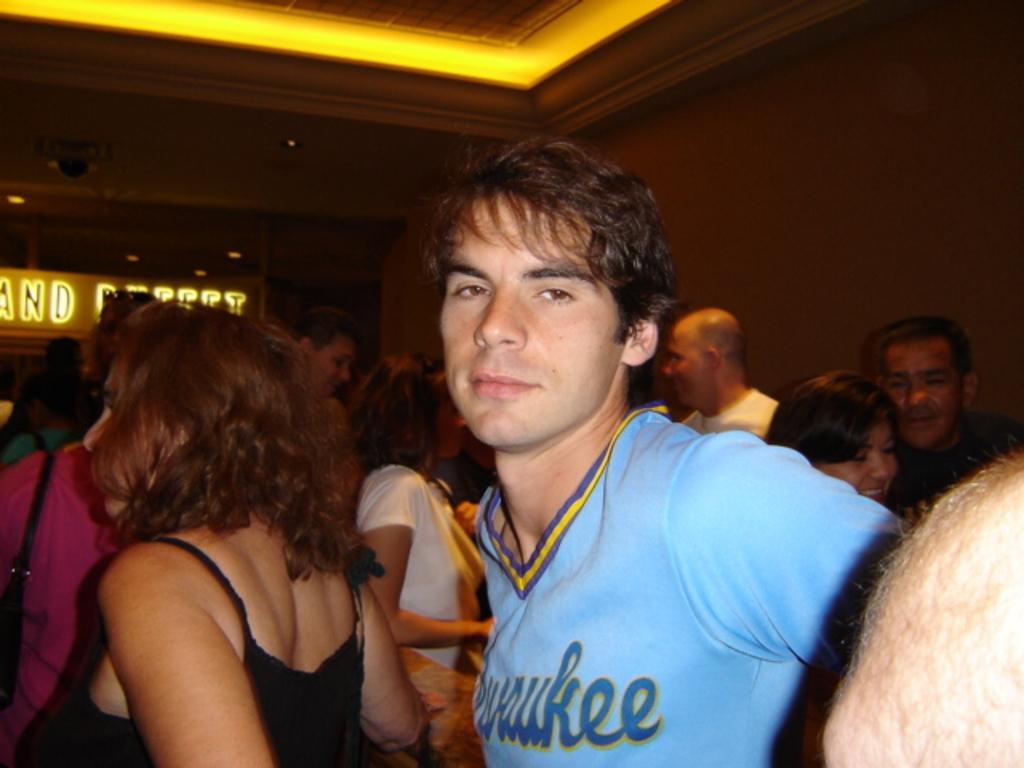How would you summarize this image in a sentence or two? In this image there are people standing, in the background there are wall, at the top there is a ceiling and lights. 